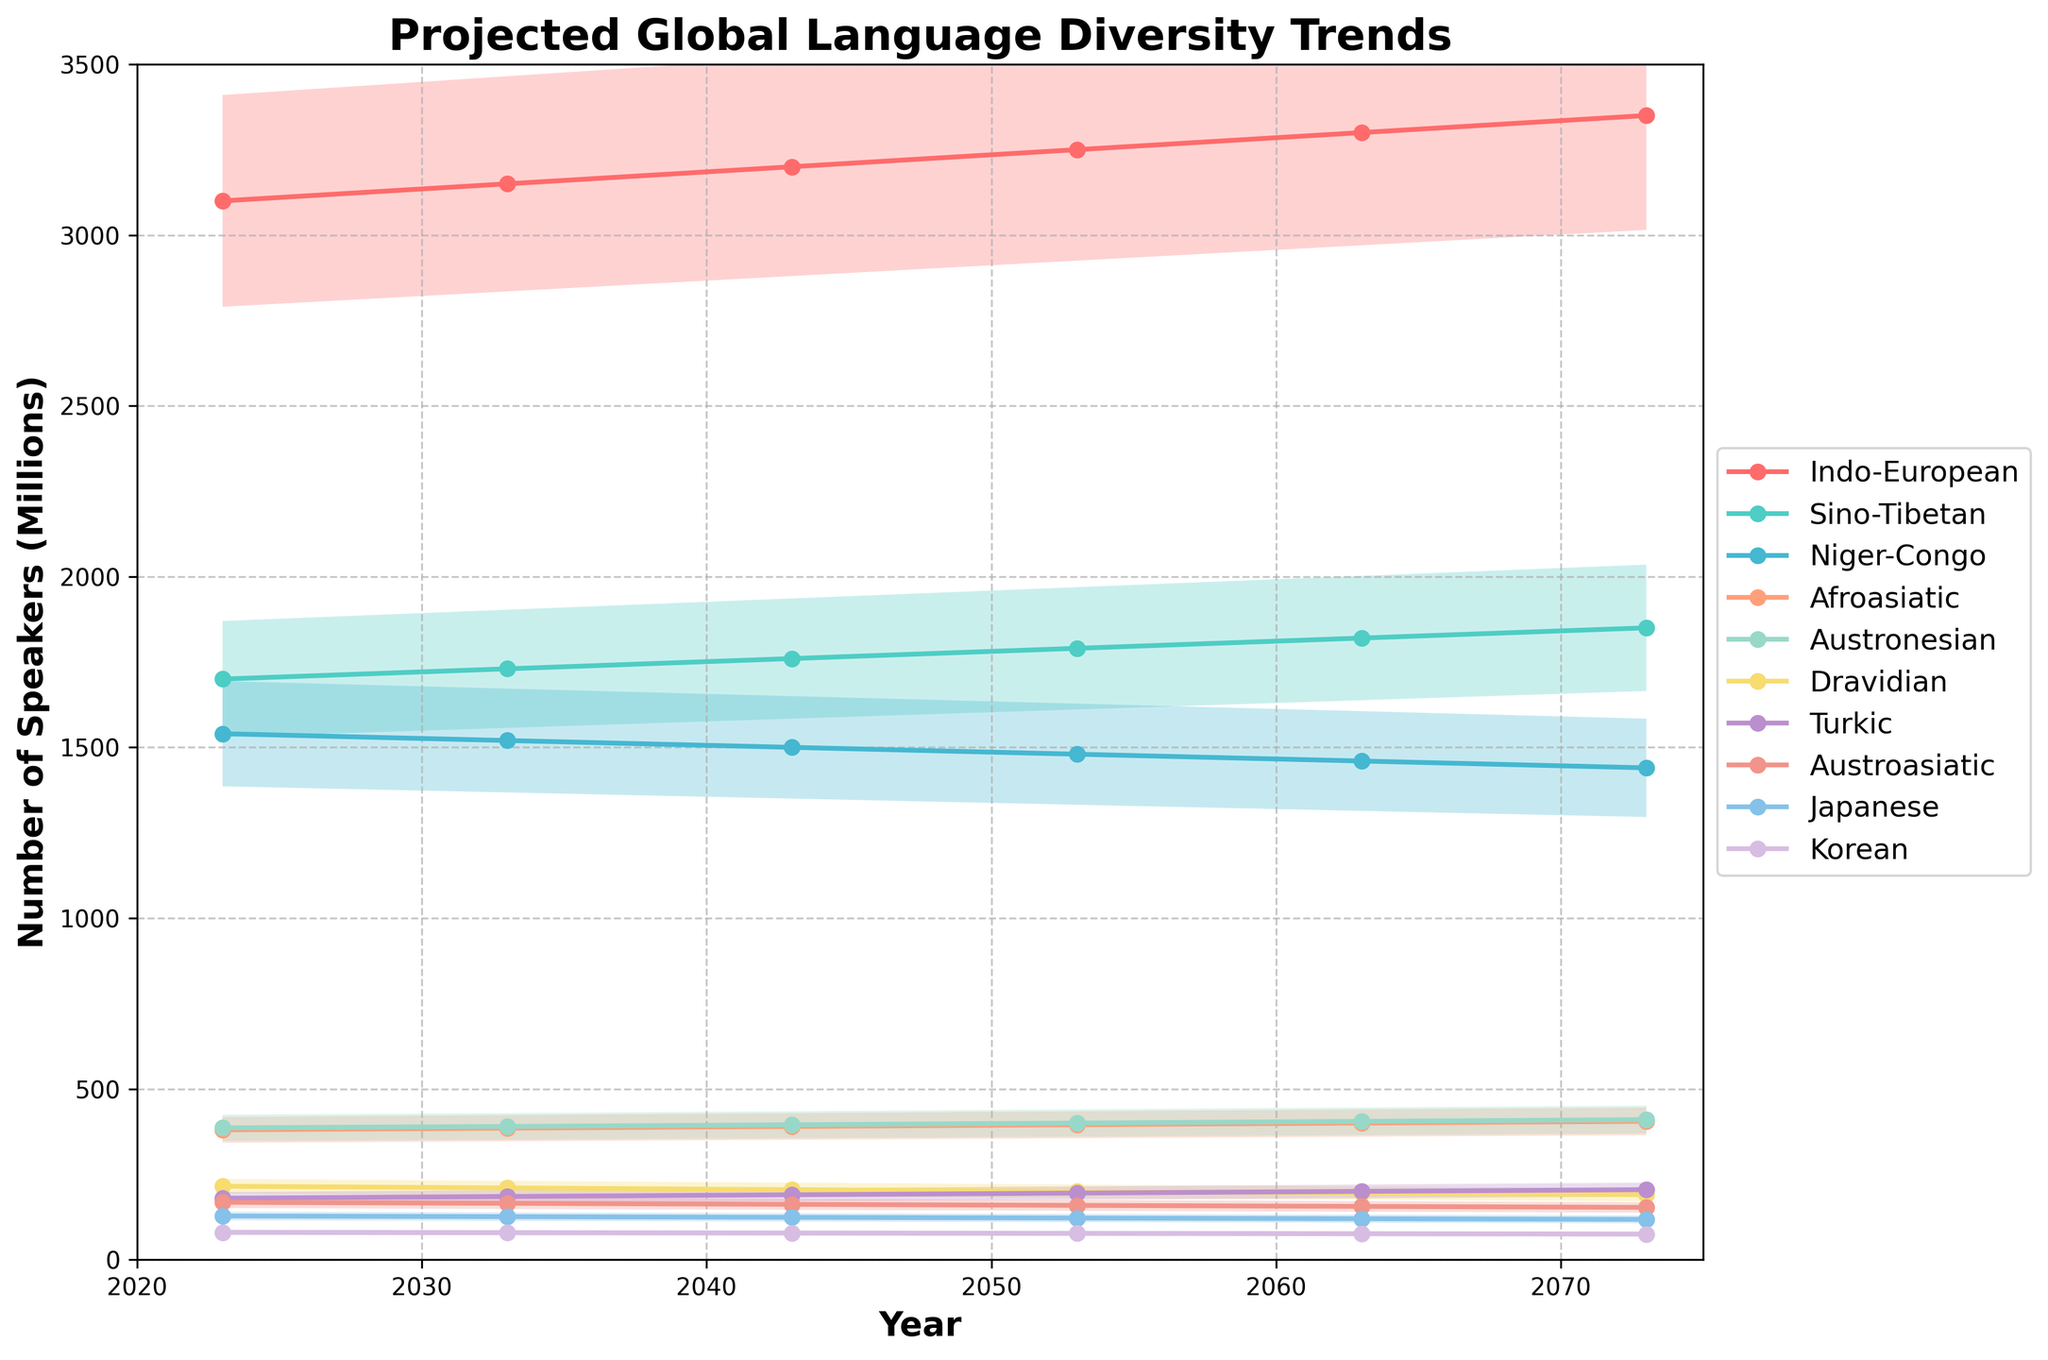What is the title of the figure? The title of the figure is located at the top and provides a summary of what the chart represents.
Answer: Projected Global Language Diversity Trends What is the range of years shown in the figure? The x-axis represents the range of years included in the chart. It starts at the leftmost point and ends at the rightmost point.
Answer: 2023-2073 Which language family has the highest number of speakers in 2073? The line representing each language family in the chart reaches different heights by 2073. The one that reaches the highest point indicates the language family with the greatest number of speakers.
Answer: Indo-European How much does the number of speakers for the Sino-Tibetan language family change from 2023 to 2073? The y-axis values for the Sino-Tibetan language family in 2023 and 2073 must be identified, and their difference calculated to determine the change.
Answer: 150 million Which language family is projected to have the steepest decline over the next 50 years? By comparing the slopes of the lines representing each language family, the one that descends the most indicates the steepest decline. The Niger-Congo family, for example, shows a clear downward trend.
Answer: Niger-Congo What is the median number of speakers projected for the Austronesian language family between 2023 and 2073? First, list the number of speakers for Austronesian in all projected years: 2023, 2033, 2043, 2053, 2063, 2073. Then, find the middle value(s) and calculate the median.
Answer: 397.5 million Which language family shows the least amount of change in the number of speakers from 2023 to 2073? By comparing the changes in y-axis values over time for each language family, the one with the smallest overall difference is identified.
Answer: Korean Which two language families have approximately converging trends by 2073? Identify the lines that come closest to each other by 2073. By inspecting the lines visually, it seems the Afroasiatic and Austronesian families are converging.
Answer: Afroasiatic and Austronesian What is the projected number of speakers for the Dravidian language family in 2053? Locate the line for the Dravidian language family and find the y-axis value corresponding to the year 2053.
Answer: 200 million By how much does the Indo-European language family grow from 2023 to 2073? Identify the y-axis values for the Indo-European language family in 2023 and 2073, respectively, and calculate the difference.
Answer: 250 million 